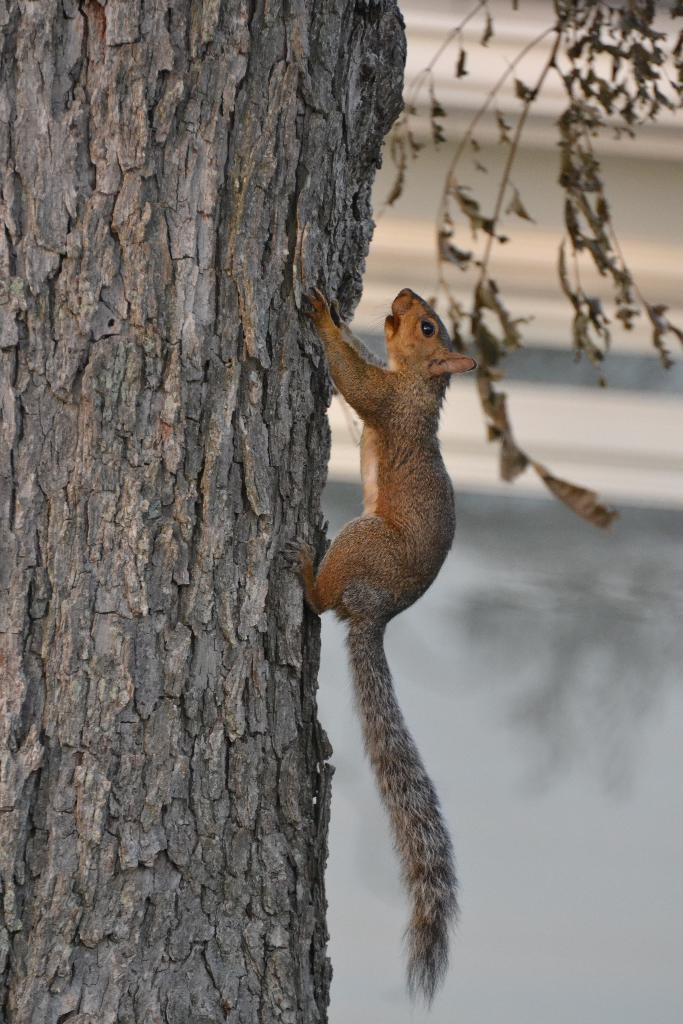What animal can be seen on the tree in the image? There is a squirrel on the bark of a tree in the image. What type of vegetation can be seen in the background of the image? Dry leaves and stems are visible in the background of the image. What type of bead is the squirrel holding in the image? There is no bead present in the image; the squirrel is on the bark of a tree. What degree of education does the squirrel have, as depicted in the image? The image does not provide any information about the squirrel's education, and squirrels do not have degrees. --- Facts: 1. There is a person holding a book in the image. 2. The person is sitting on a chair. 3. The chair is made of wood. 4. The book has a blue cover. Absurd Topics: fish, ocean, boat Conversation: What is the person in the image holding? The person in the image is holding a book. What is the person's position in the image? The person is sitting on a chair. What material is the chair made of? The chair is made of wood. What color is the book's cover? The book has a blue cover. Reasoning: Let's think step by step in order to produce the conversation. We start by identifying the main subject in the image, which is the person holding a book. Then, we expand the conversation to include other elements in the image, such as the person's position on the chair and the chair's material. Finally, we mention a detail about the book itself, which is its blue cover. Each question is designed to elicit a specific detail about the image that is known from the provided facts. Absurd Question/Answer: Can you see any fish swimming in the ocean in the image? There is no ocean or fish present in the image; it features a person sitting on a wooden chair holding a book with a blue cover. 